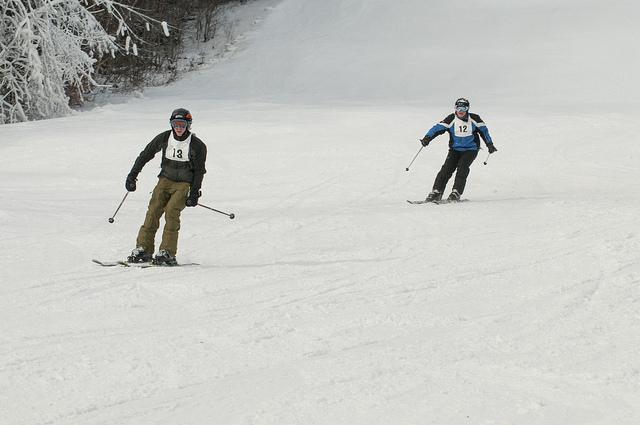How many athletes are there?
Keep it brief. 2. Are the skiers male or female?
Keep it brief. Male. Are they racing?
Quick response, please. Yes. Is the man squatting?
Keep it brief. No. Are they going uphill or downhill?
Answer briefly. Downhill. What are they using to stay upright?
Short answer required. Poles. What is the person on?
Give a very brief answer. Skis. What is the man doing?
Write a very short answer. Skiing. How many people are there?
Answer briefly. 2. How many people are wearing goggles?
Write a very short answer. 2. 